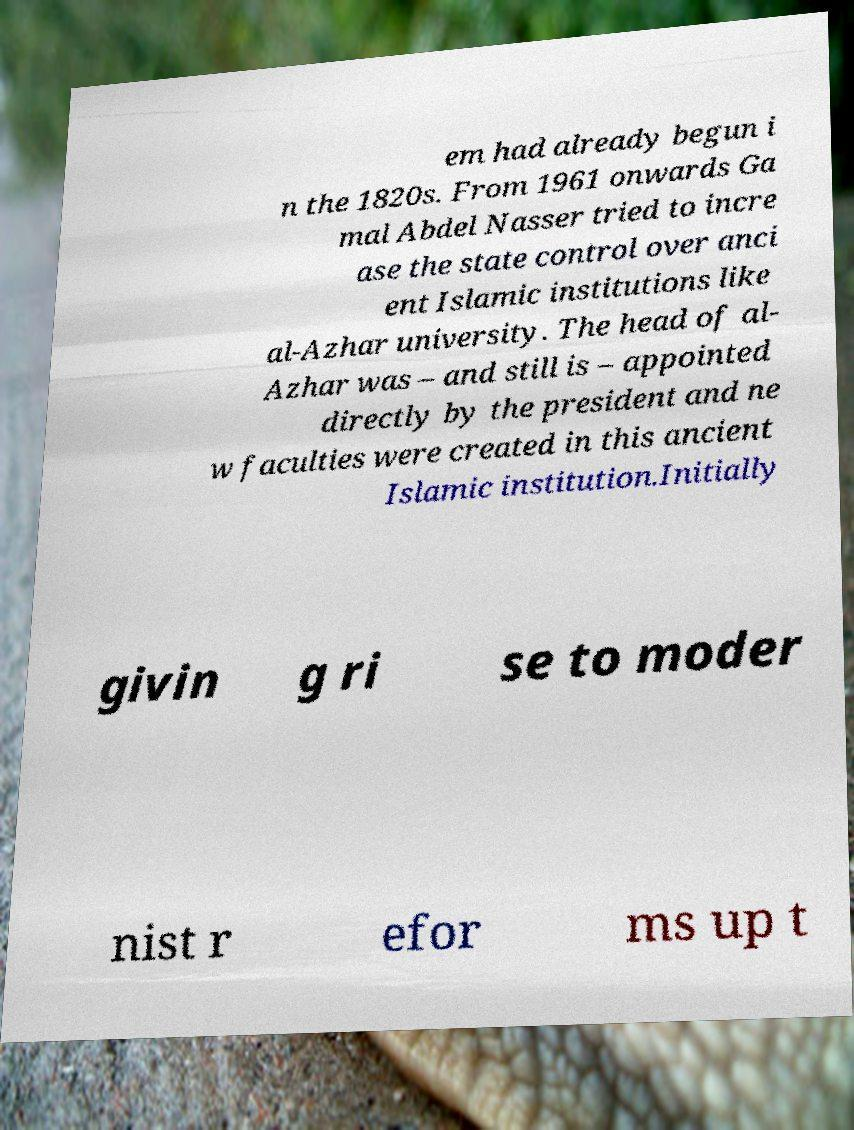Can you accurately transcribe the text from the provided image for me? em had already begun i n the 1820s. From 1961 onwards Ga mal Abdel Nasser tried to incre ase the state control over anci ent Islamic institutions like al-Azhar university. The head of al- Azhar was – and still is – appointed directly by the president and ne w faculties were created in this ancient Islamic institution.Initially givin g ri se to moder nist r efor ms up t 